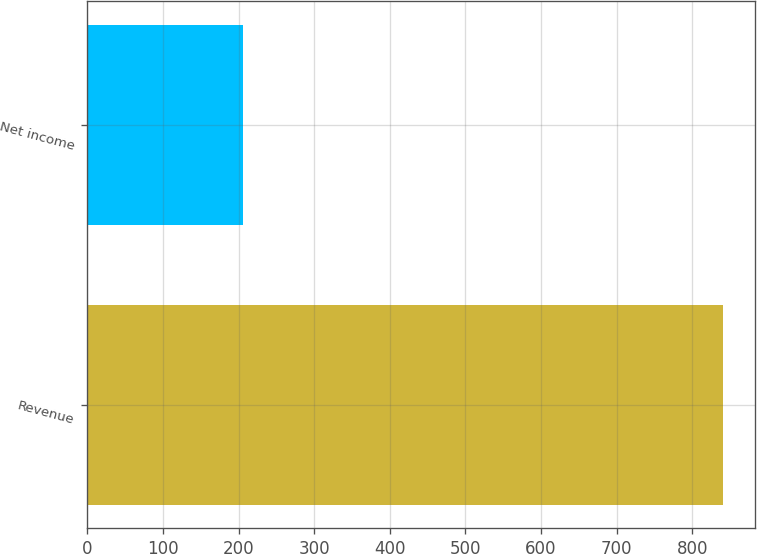Convert chart. <chart><loc_0><loc_0><loc_500><loc_500><bar_chart><fcel>Revenue<fcel>Net income<nl><fcel>840.9<fcel>205.6<nl></chart> 